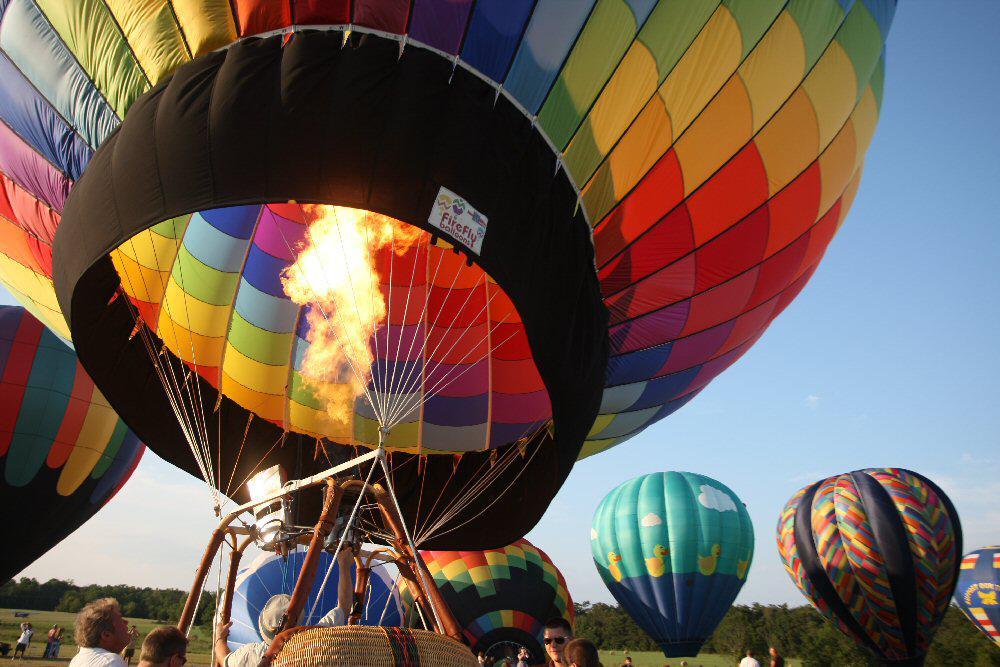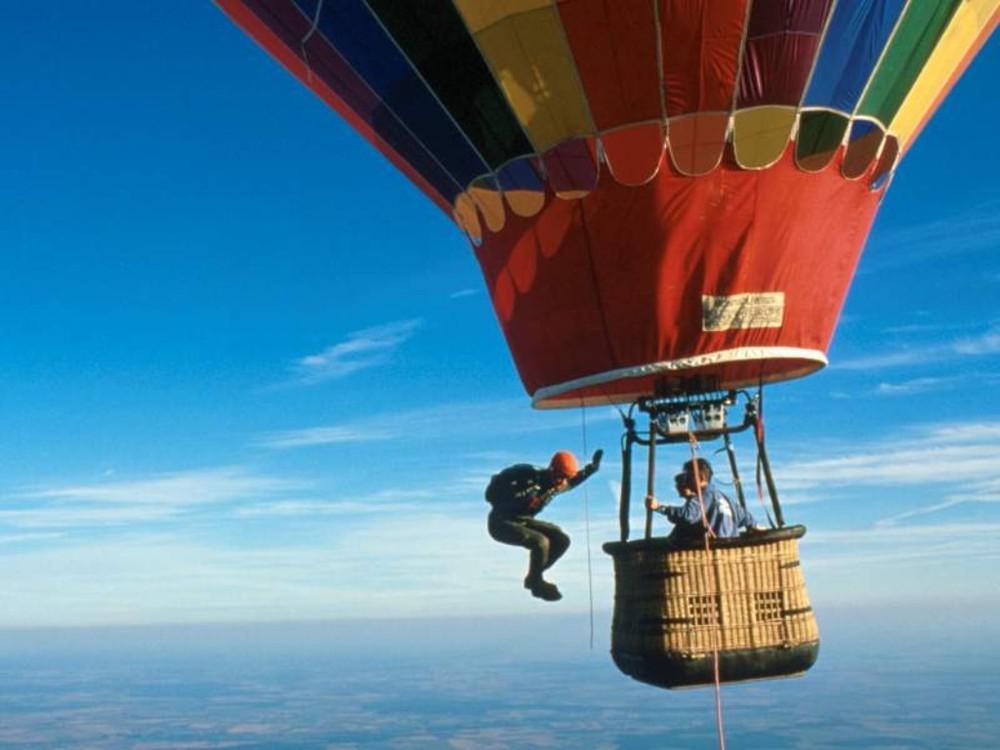The first image is the image on the left, the second image is the image on the right. For the images shown, is this caption "An image shows the bright light of a flame inside a multi-colored hot-air balloon." true? Answer yes or no. Yes. 